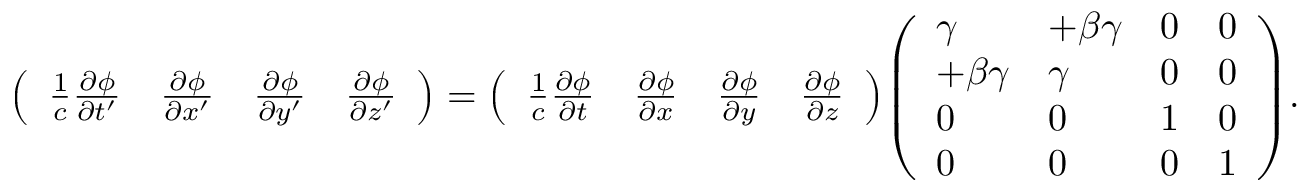Convert formula to latex. <formula><loc_0><loc_0><loc_500><loc_500>{ \left ( \begin{array} { l l l l } { { \frac { 1 } { c } } { \frac { \partial \phi } { \partial t ^ { \prime } } } } & { { \frac { \partial \phi } { \partial x ^ { \prime } } } } & { { \frac { \partial \phi } { \partial y ^ { \prime } } } } & { { \frac { \partial \phi } { \partial z ^ { \prime } } } } \end{array} \right ) } = { \left ( \begin{array} { l l l l } { { \frac { 1 } { c } } { \frac { \partial \phi } { \partial t } } } & { { \frac { \partial \phi } { \partial x } } } & { { \frac { \partial \phi } { \partial y } } } & { { \frac { \partial \phi } { \partial z } } } \end{array} \right ) } { \left ( \begin{array} { l l l l } { \gamma } & { + \beta \gamma } & { 0 } & { 0 } \\ { + \beta \gamma } & { \gamma } & { 0 } & { 0 } \\ { 0 } & { 0 } & { 1 } & { 0 } \\ { 0 } & { 0 } & { 0 } & { 1 } \end{array} \right ) } .</formula> 